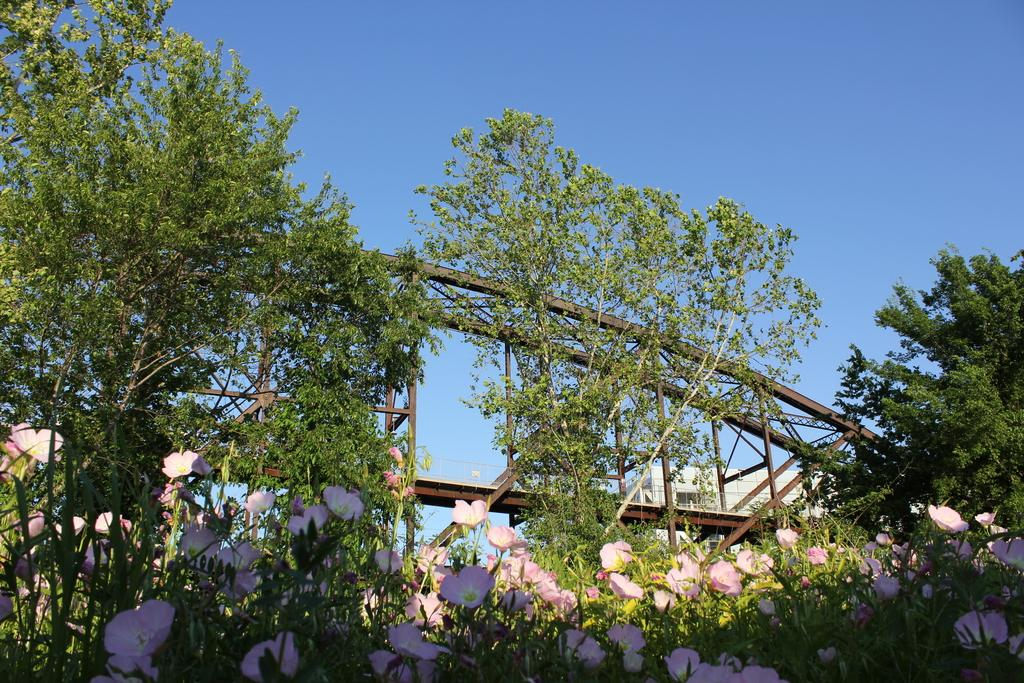What color are the flowers in the image? The flowers in the image are pink. What can be seen in the background of the image? There are trees in green color in the background of the image. What is the color of the building in the image? The building in the image is white. What color is the sky in the image? The sky is blue in the image. Can you see a dog wearing a yoke in the image? No, there is no dog or yoke present in the image. What type of pipe is visible in the image? There is no pipe present in the image. 